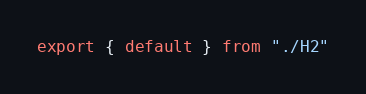Convert code to text. <code><loc_0><loc_0><loc_500><loc_500><_JavaScript_>export { default } from "./H2"</code> 